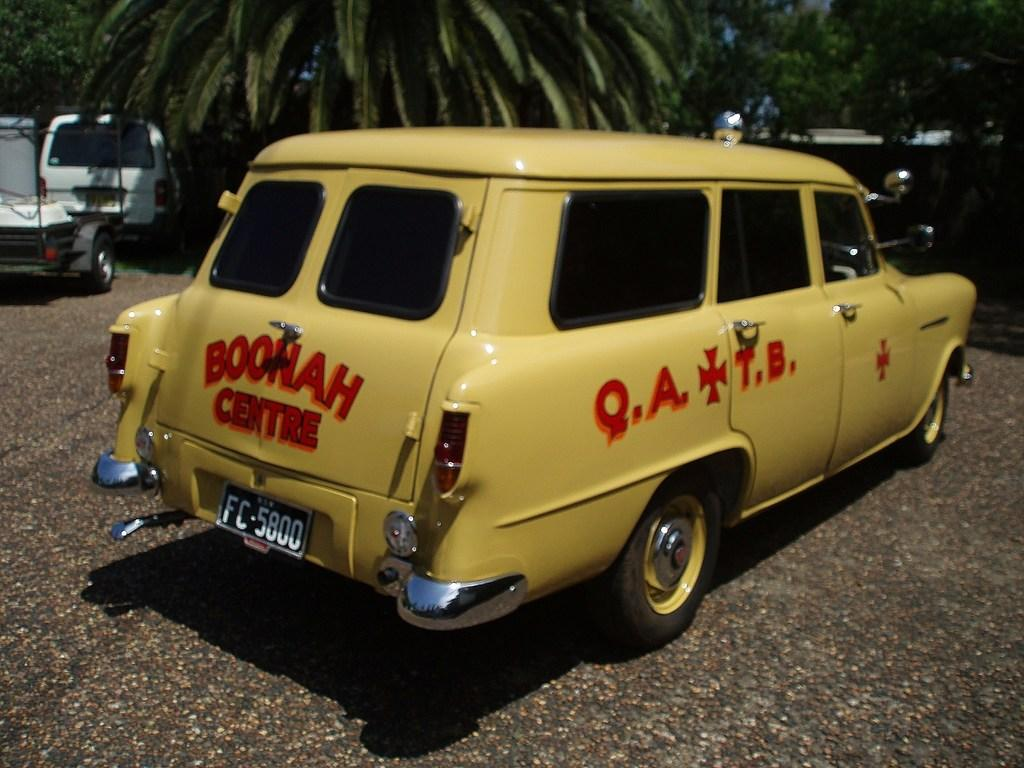What is the main subject in the center of the image? There is a car in the center of the image. Can you describe the background of the image? There are cars and trees in the background of the image. What type of pickle is being used as a steering wheel in the car? There is no pickle present in the image, nor is it being used as a steering wheel. 